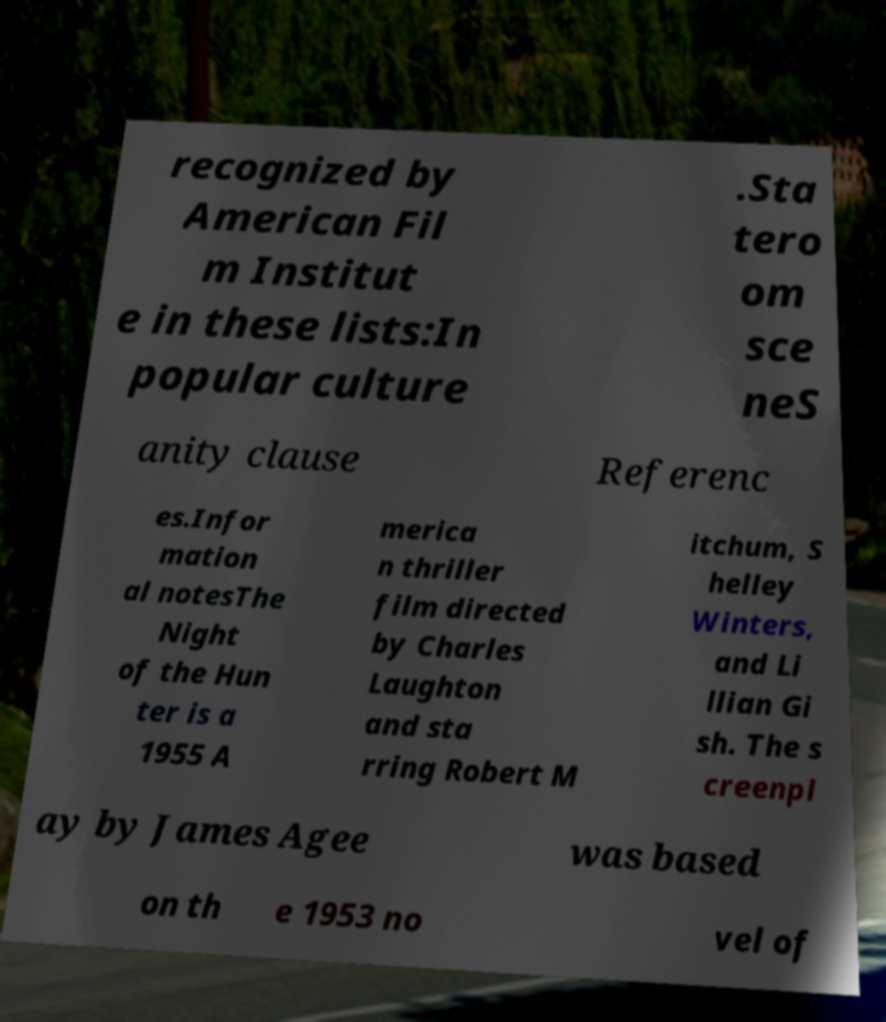Could you assist in decoding the text presented in this image and type it out clearly? recognized by American Fil m Institut e in these lists:In popular culture .Sta tero om sce neS anity clause Referenc es.Infor mation al notesThe Night of the Hun ter is a 1955 A merica n thriller film directed by Charles Laughton and sta rring Robert M itchum, S helley Winters, and Li llian Gi sh. The s creenpl ay by James Agee was based on th e 1953 no vel of 